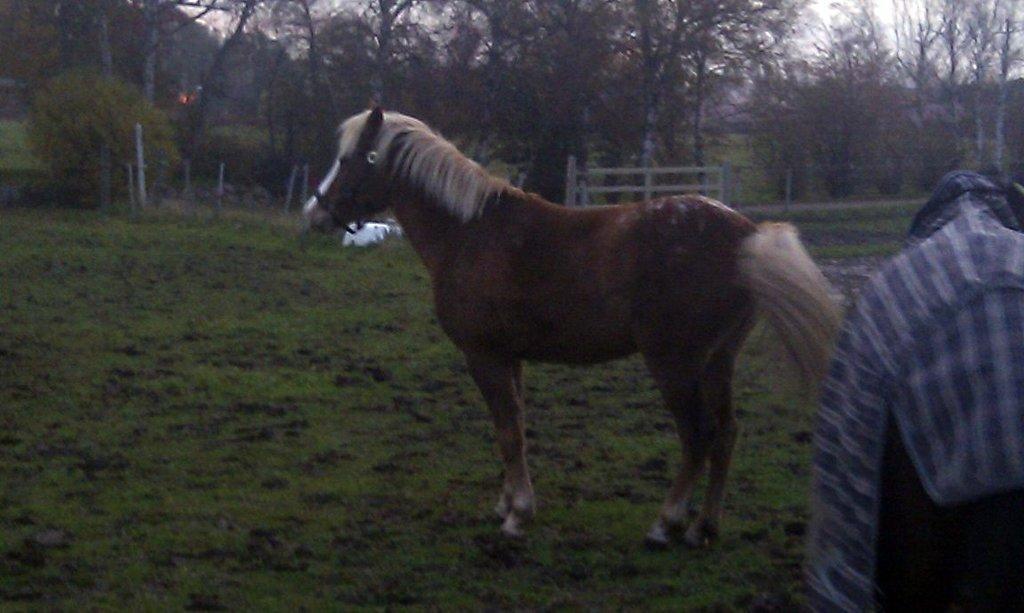Describe this image in one or two sentences. In the picture I can see a horse on the ground and here I can see the shirt on the right side of the image. In the background, I can see the fence and trees. 